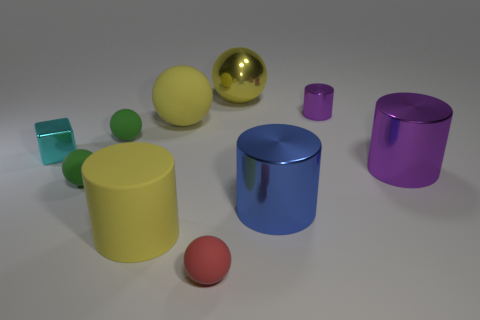What is the material of the cylinder that is the same color as the big shiny ball?
Offer a very short reply. Rubber. What is the yellow thing that is in front of the tiny green sphere in front of the object right of the small purple shiny object made of?
Your response must be concise. Rubber. Is the color of the big cylinder to the left of the red matte sphere the same as the small shiny block?
Keep it short and to the point. No. There is a large thing that is to the left of the big blue shiny cylinder and on the right side of the tiny red thing; what material is it?
Your answer should be compact. Metal. Is there a gray matte sphere of the same size as the red rubber ball?
Give a very brief answer. No. How many red balls are there?
Offer a very short reply. 1. There is a red rubber object; what number of green rubber balls are behind it?
Provide a short and direct response. 2. Is the blue cylinder made of the same material as the large purple object?
Make the answer very short. Yes. What number of small objects are behind the big yellow cylinder and right of the cyan thing?
Ensure brevity in your answer.  3. How many other things are there of the same color as the large rubber sphere?
Offer a very short reply. 2. 